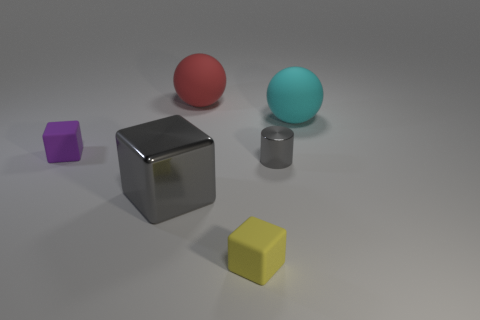What is the shape of the large cyan thing that is the same material as the purple thing?
Your response must be concise. Sphere. There is a red rubber thing that is the same size as the gray cube; what shape is it?
Offer a terse response. Sphere. Are there the same number of red rubber things in front of the large gray thing and yellow rubber objects that are to the right of the purple cube?
Keep it short and to the point. No. Do the big cyan rubber object and the tiny rubber object in front of the tiny purple thing have the same shape?
Offer a terse response. No. How many other objects are the same material as the small yellow cube?
Keep it short and to the point. 3. Are there any matte objects right of the red matte sphere?
Ensure brevity in your answer.  Yes. There is a cyan matte thing; is its size the same as the rubber ball left of the large cyan matte sphere?
Your response must be concise. Yes. What is the color of the matte block on the left side of the shiny object that is to the left of the gray shiny cylinder?
Give a very brief answer. Purple. Do the purple rubber object and the red thing have the same size?
Offer a terse response. No. What is the color of the thing that is in front of the tiny gray shiny cylinder and left of the yellow matte thing?
Provide a succinct answer. Gray. 